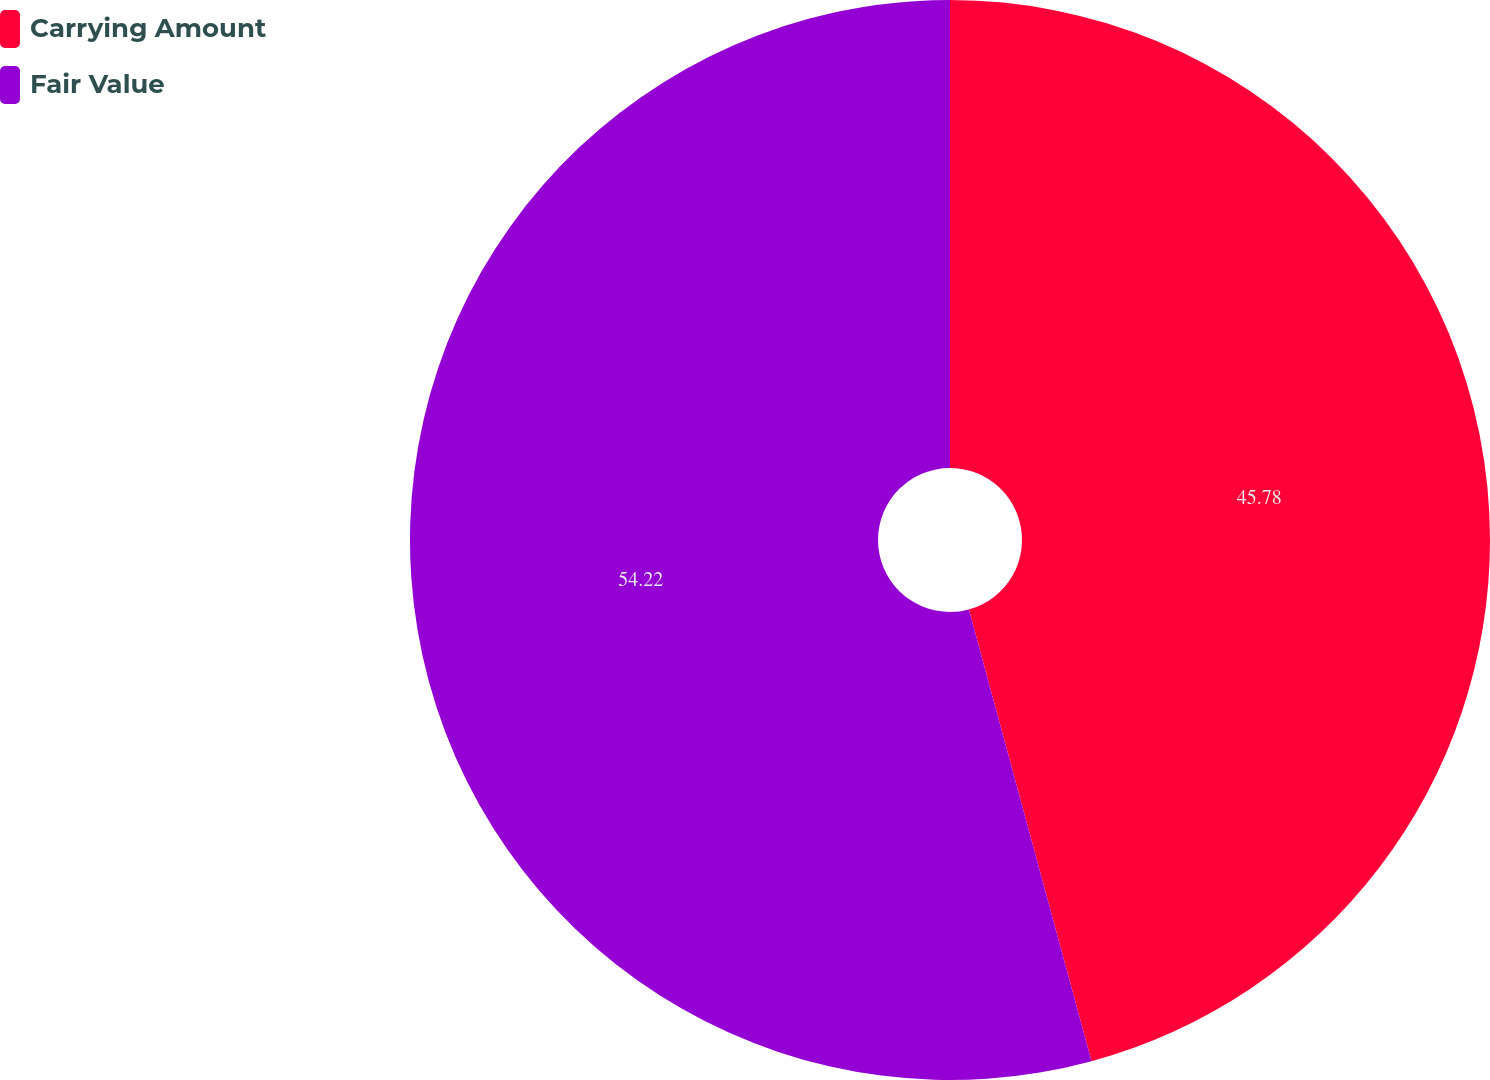<chart> <loc_0><loc_0><loc_500><loc_500><pie_chart><fcel>Carrying Amount<fcel>Fair Value<nl><fcel>45.78%<fcel>54.22%<nl></chart> 